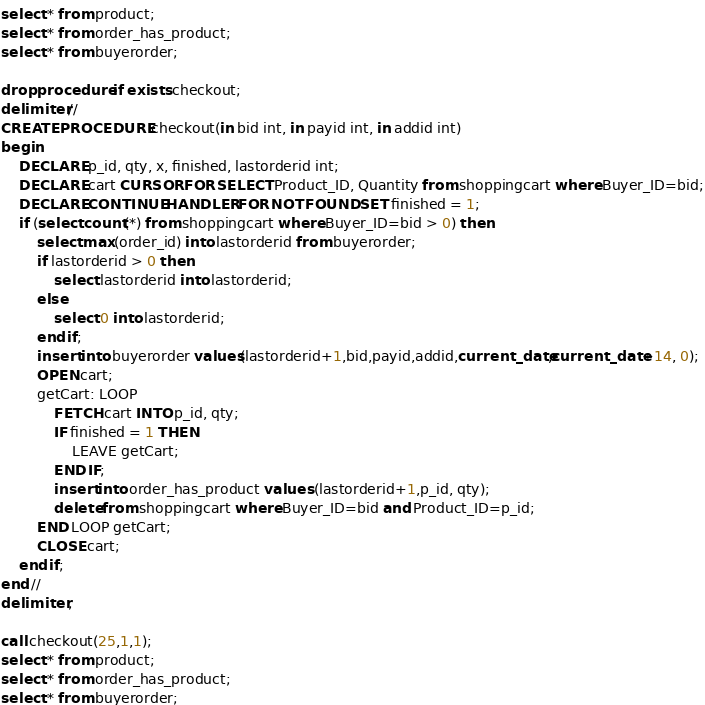<code> <loc_0><loc_0><loc_500><loc_500><_SQL_>select * from product;
select * from order_has_product;
select * from buyerorder;

drop procedure if exists checkout;
delimiter //
CREATE PROCEDURE checkout(in bid int, in payid int, in addid int)
begin
    DECLARE p_id, qty, x, finished, lastorderid int;
    DECLARE cart CURSOR FOR SELECT Product_ID, Quantity from shoppingcart where Buyer_ID=bid;
    DECLARE CONTINUE HANDLER FOR NOT FOUND SET finished = 1;
    if (select count(*) from shoppingcart where Buyer_ID=bid > 0) then
		select max(order_id) into lastorderid from buyerorder;
        if lastorderid > 0 then
			select lastorderid into lastorderid;
		else
			select 0 into lastorderid;
		end if;
		insert into buyerorder values(lastorderid+1,bid,payid,addid,current_date,current_date+14, 0);
		OPEN cart;
		getCart: LOOP
			FETCH cart INTO p_id, qty;
			IF finished = 1 THEN 
				LEAVE getCart;
			END IF;
			insert into order_has_product values (lastorderid+1,p_id, qty);
			delete from shoppingcart where Buyer_ID=bid and Product_ID=p_id;
		END LOOP getCart;
		CLOSE cart;
    end if;
end //
delimiter ;

call checkout(25,1,1);
select * from product;
select * from order_has_product;
select * from buyerorder;</code> 